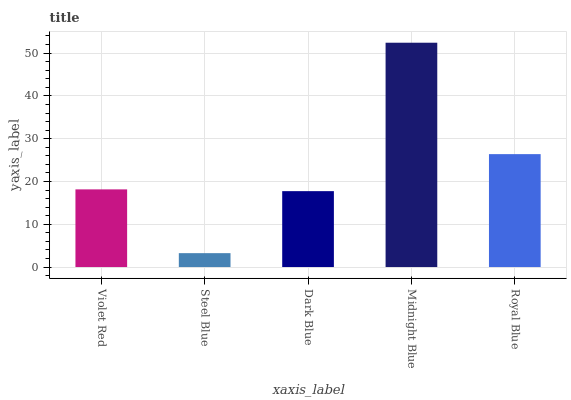Is Dark Blue the minimum?
Answer yes or no. No. Is Dark Blue the maximum?
Answer yes or no. No. Is Dark Blue greater than Steel Blue?
Answer yes or no. Yes. Is Steel Blue less than Dark Blue?
Answer yes or no. Yes. Is Steel Blue greater than Dark Blue?
Answer yes or no. No. Is Dark Blue less than Steel Blue?
Answer yes or no. No. Is Violet Red the high median?
Answer yes or no. Yes. Is Violet Red the low median?
Answer yes or no. Yes. Is Steel Blue the high median?
Answer yes or no. No. Is Steel Blue the low median?
Answer yes or no. No. 